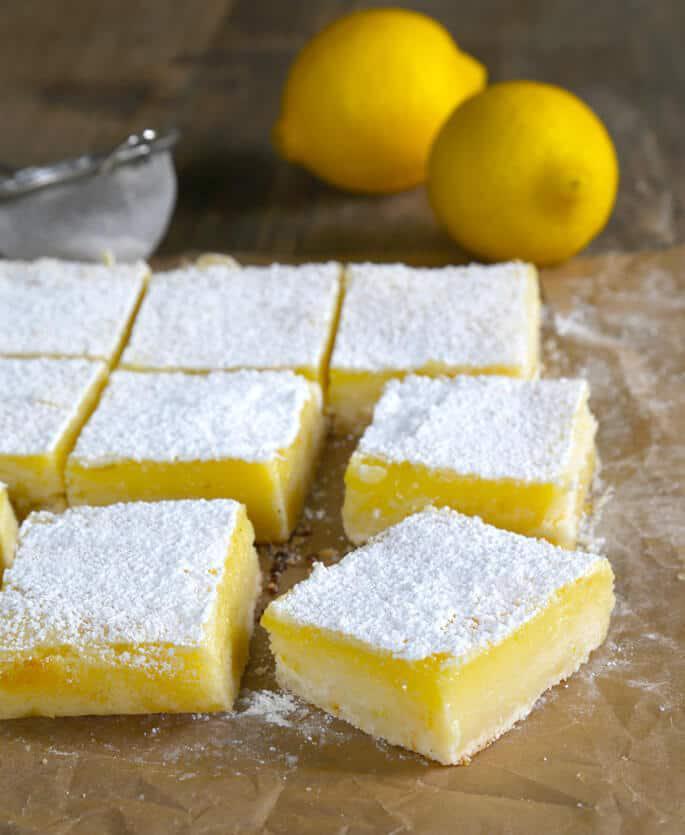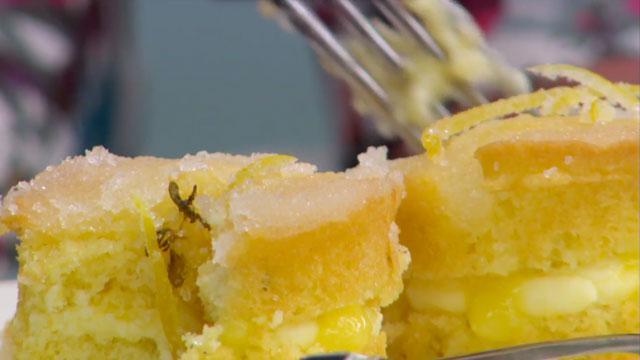The first image is the image on the left, the second image is the image on the right. For the images shown, is this caption "There are at least 8 lemons." true? Answer yes or no. No. The first image is the image on the left, the second image is the image on the right. Considering the images on both sides, is "There are more than two whole lemons." valid? Answer yes or no. No. 